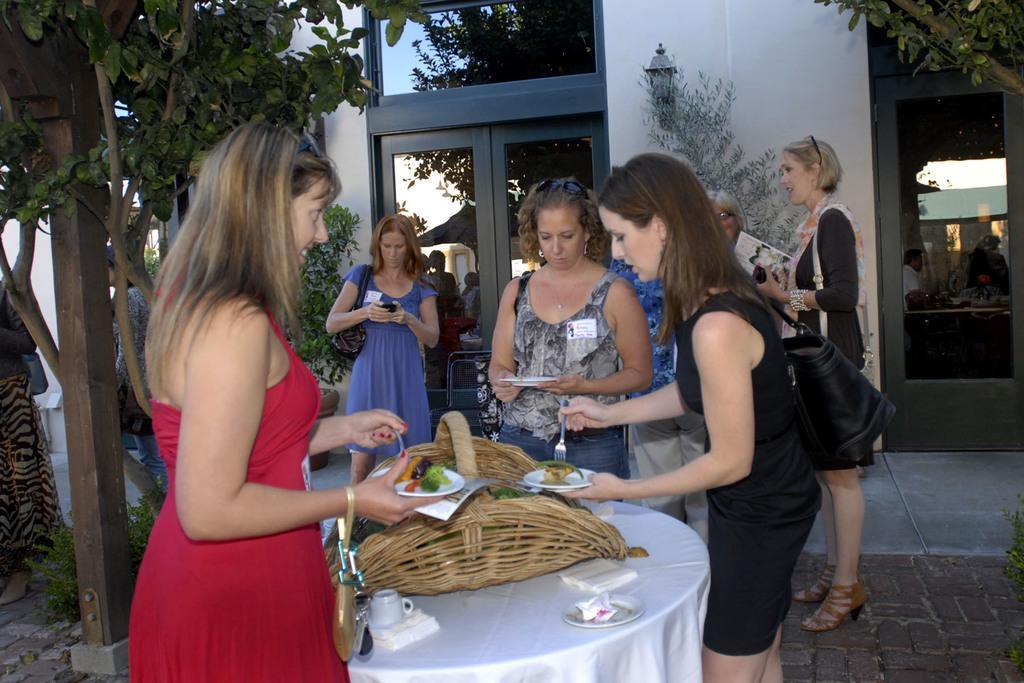In one or two sentences, can you explain what this image depicts? In this picture we can see group of woman standing at table and on table we can see basket, cup, saucer, tissue paper and this two woman are holding plate and on plate we have food and forks in their hands in background we can see woman looking at mobile and we have glass door,wall, lamp, tree. 